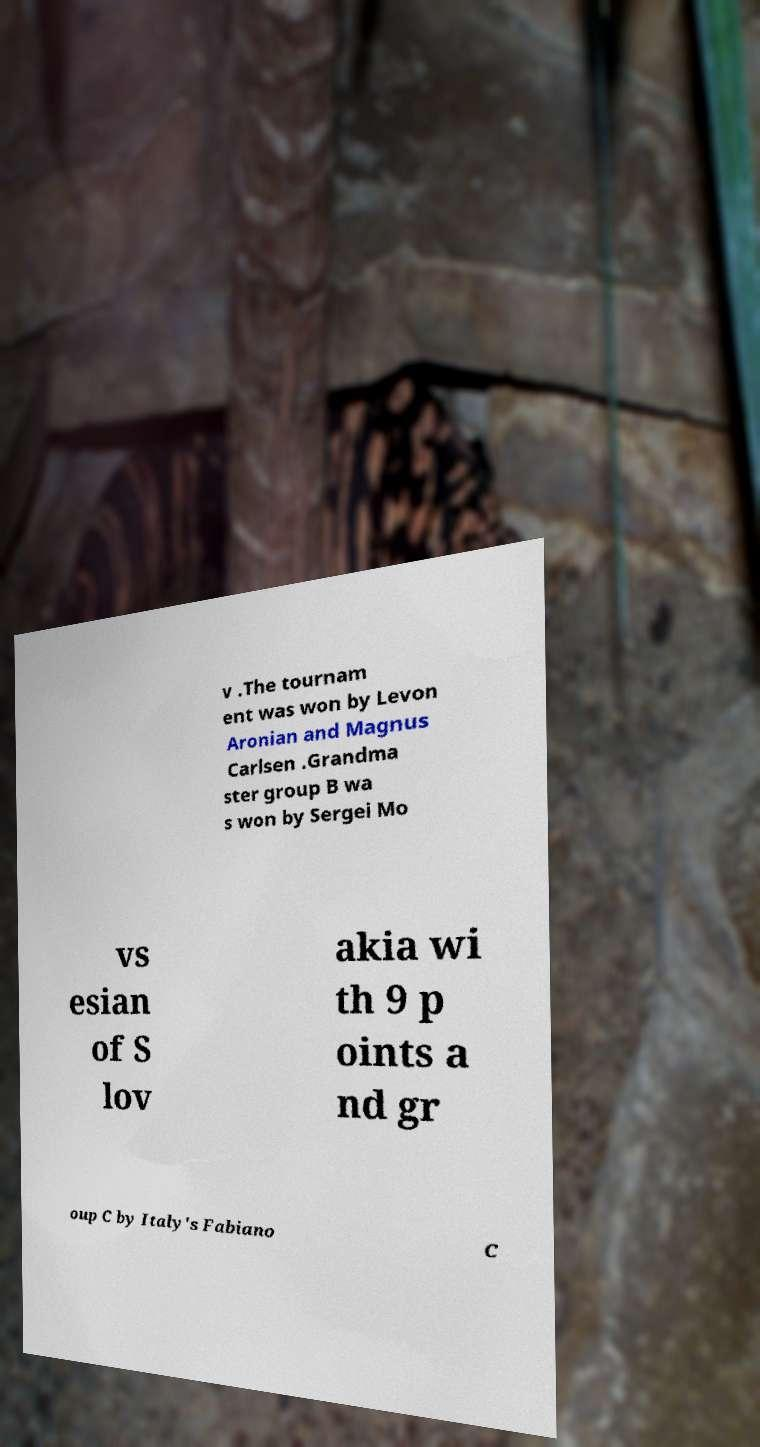Can you read and provide the text displayed in the image?This photo seems to have some interesting text. Can you extract and type it out for me? v .The tournam ent was won by Levon Aronian and Magnus Carlsen .Grandma ster group B wa s won by Sergei Mo vs esian of S lov akia wi th 9 p oints a nd gr oup C by Italy's Fabiano C 